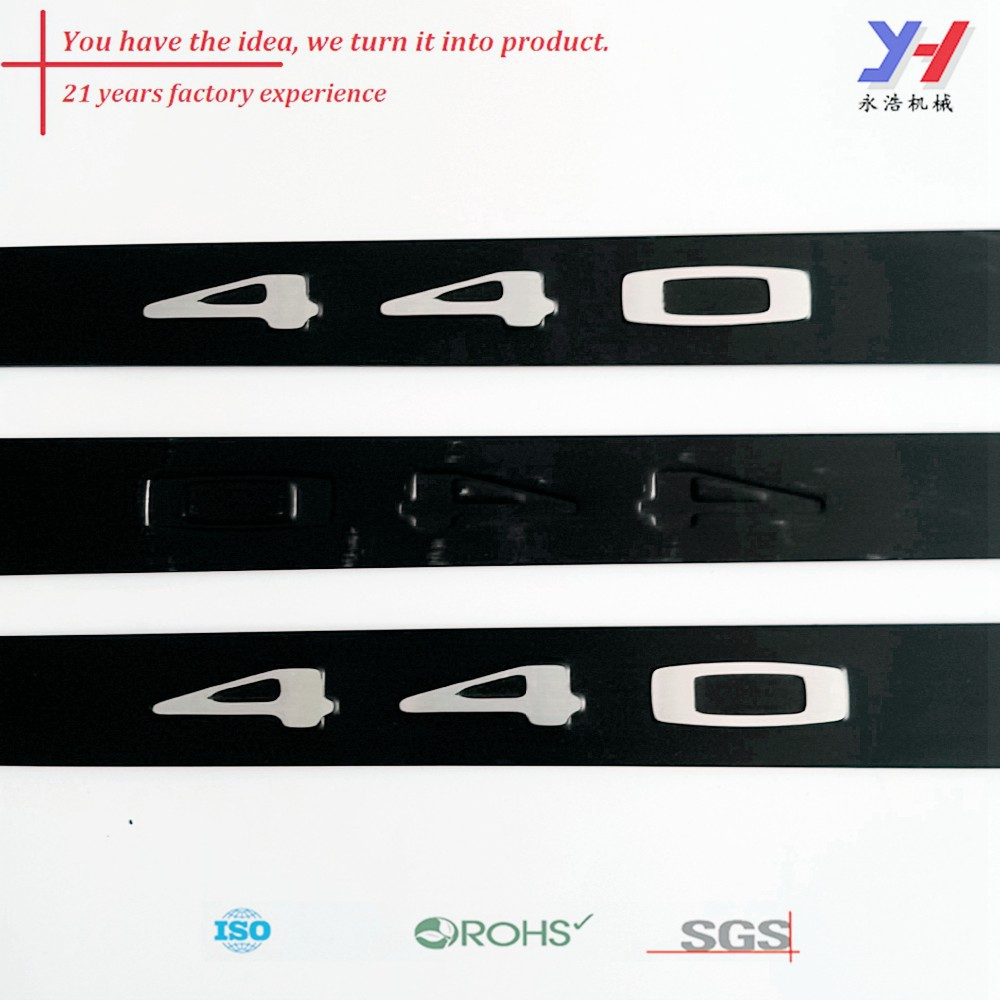Can you describe the design elements of the '40' logo featured in the image? The design elements of the '40' logo in the image are minimalistic yet striking. The numbers are crafted in a sleek, modern font and presented in a reflective, metallic finish. This stylized presentation is set against a dark background, creating a strong visual contrast that draws attention to the numbers. The design exudes a sense of precision and quality, likely intended to convey the company's commitment to excellence and innovation. What could the combination of '21 years factory experience' and '40' signify together? The combination of '21 years factory experience' and '40' might signify a dual emphasis on the company’s long-standing industry expertise and a significant milestone or innovation, such as their 40th product line or a model series numbered '40'. This pairing suggests a narrative of growth and achievement, celebrating both the company's extensive experience and a pivotal product that embodies their engineering prowess and market evolution. 